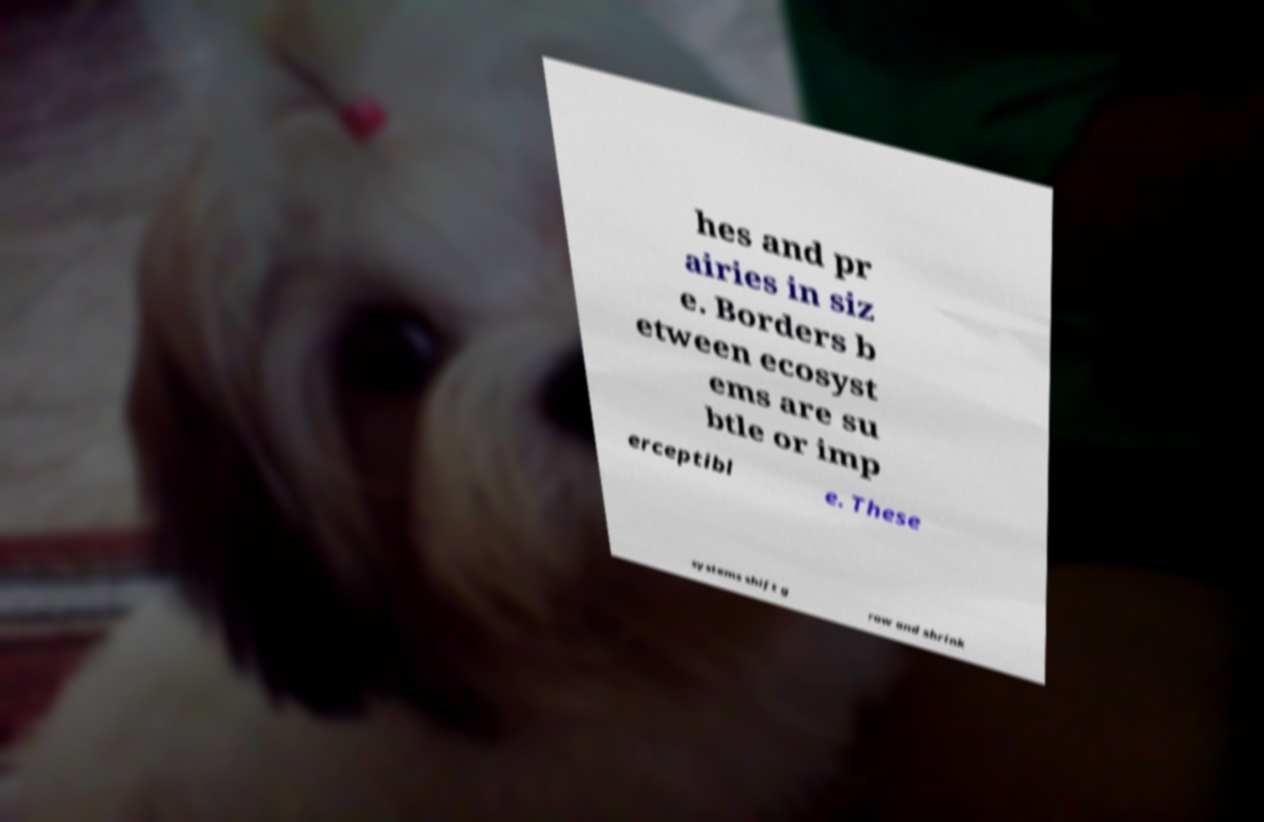What messages or text are displayed in this image? I need them in a readable, typed format. hes and pr airies in siz e. Borders b etween ecosyst ems are su btle or imp erceptibl e. These systems shift g row and shrink 